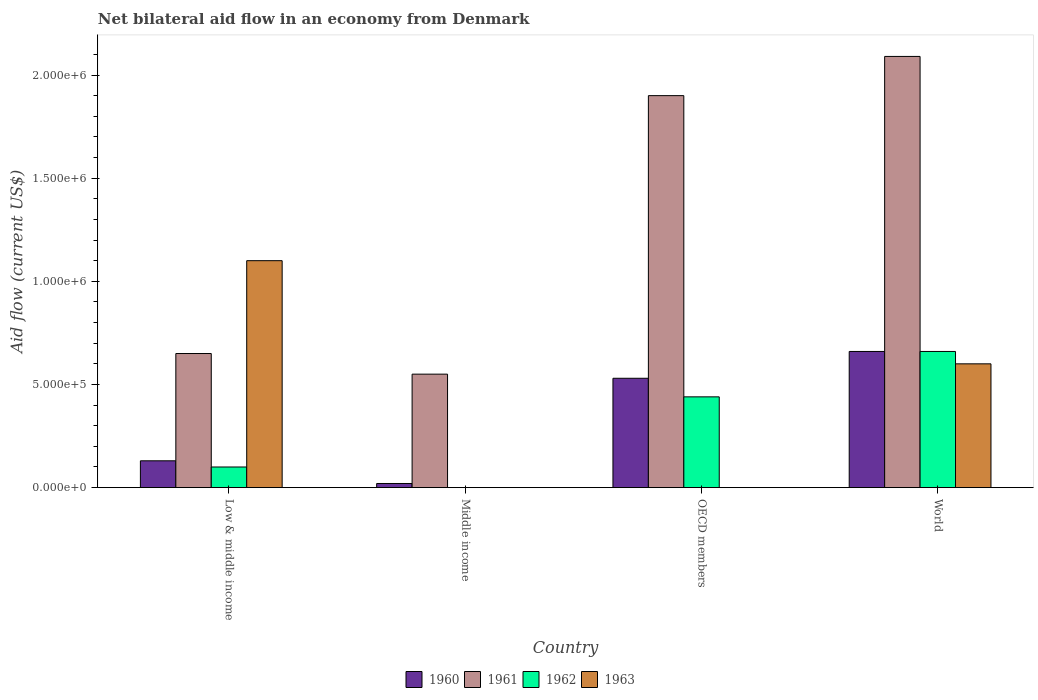How many different coloured bars are there?
Give a very brief answer. 4. Are the number of bars per tick equal to the number of legend labels?
Offer a terse response. No. Are the number of bars on each tick of the X-axis equal?
Make the answer very short. No. How many bars are there on the 4th tick from the left?
Offer a terse response. 4. How many bars are there on the 2nd tick from the right?
Ensure brevity in your answer.  3. In how many cases, is the number of bars for a given country not equal to the number of legend labels?
Make the answer very short. 2. What is the net bilateral aid flow in 1960 in OECD members?
Provide a short and direct response. 5.30e+05. Across all countries, what is the maximum net bilateral aid flow in 1961?
Offer a very short reply. 2.09e+06. In which country was the net bilateral aid flow in 1963 maximum?
Provide a succinct answer. Low & middle income. What is the total net bilateral aid flow in 1963 in the graph?
Your answer should be compact. 1.70e+06. What is the difference between the net bilateral aid flow in 1962 in OECD members and that in World?
Your answer should be very brief. -2.20e+05. What is the average net bilateral aid flow in 1960 per country?
Make the answer very short. 3.35e+05. What is the ratio of the net bilateral aid flow in 1961 in OECD members to that in World?
Ensure brevity in your answer.  0.91. Is the net bilateral aid flow in 1962 in Low & middle income less than that in World?
Provide a succinct answer. Yes. Is the difference between the net bilateral aid flow in 1963 in Low & middle income and World greater than the difference between the net bilateral aid flow in 1961 in Low & middle income and World?
Offer a terse response. Yes. What is the difference between the highest and the second highest net bilateral aid flow in 1961?
Make the answer very short. 1.44e+06. What is the difference between the highest and the lowest net bilateral aid flow in 1961?
Keep it short and to the point. 1.54e+06. Is it the case that in every country, the sum of the net bilateral aid flow in 1961 and net bilateral aid flow in 1962 is greater than the sum of net bilateral aid flow in 1960 and net bilateral aid flow in 1963?
Your answer should be compact. No. Is it the case that in every country, the sum of the net bilateral aid flow in 1960 and net bilateral aid flow in 1961 is greater than the net bilateral aid flow in 1962?
Offer a very short reply. Yes. How many bars are there?
Provide a short and direct response. 13. What is the difference between two consecutive major ticks on the Y-axis?
Make the answer very short. 5.00e+05. Are the values on the major ticks of Y-axis written in scientific E-notation?
Provide a succinct answer. Yes. Does the graph contain any zero values?
Offer a terse response. Yes. Does the graph contain grids?
Ensure brevity in your answer.  No. What is the title of the graph?
Provide a short and direct response. Net bilateral aid flow in an economy from Denmark. What is the Aid flow (current US$) in 1961 in Low & middle income?
Offer a very short reply. 6.50e+05. What is the Aid flow (current US$) in 1962 in Low & middle income?
Offer a terse response. 1.00e+05. What is the Aid flow (current US$) of 1963 in Low & middle income?
Your response must be concise. 1.10e+06. What is the Aid flow (current US$) in 1961 in Middle income?
Offer a terse response. 5.50e+05. What is the Aid flow (current US$) of 1962 in Middle income?
Your answer should be compact. 0. What is the Aid flow (current US$) of 1960 in OECD members?
Provide a short and direct response. 5.30e+05. What is the Aid flow (current US$) of 1961 in OECD members?
Keep it short and to the point. 1.90e+06. What is the Aid flow (current US$) in 1962 in OECD members?
Offer a very short reply. 4.40e+05. What is the Aid flow (current US$) in 1960 in World?
Ensure brevity in your answer.  6.60e+05. What is the Aid flow (current US$) of 1961 in World?
Give a very brief answer. 2.09e+06. Across all countries, what is the maximum Aid flow (current US$) of 1961?
Provide a succinct answer. 2.09e+06. Across all countries, what is the maximum Aid flow (current US$) in 1963?
Your answer should be very brief. 1.10e+06. Across all countries, what is the minimum Aid flow (current US$) in 1962?
Keep it short and to the point. 0. Across all countries, what is the minimum Aid flow (current US$) in 1963?
Your response must be concise. 0. What is the total Aid flow (current US$) in 1960 in the graph?
Your response must be concise. 1.34e+06. What is the total Aid flow (current US$) in 1961 in the graph?
Ensure brevity in your answer.  5.19e+06. What is the total Aid flow (current US$) in 1962 in the graph?
Provide a succinct answer. 1.20e+06. What is the total Aid flow (current US$) in 1963 in the graph?
Give a very brief answer. 1.70e+06. What is the difference between the Aid flow (current US$) in 1960 in Low & middle income and that in OECD members?
Your answer should be compact. -4.00e+05. What is the difference between the Aid flow (current US$) of 1961 in Low & middle income and that in OECD members?
Your answer should be compact. -1.25e+06. What is the difference between the Aid flow (current US$) in 1962 in Low & middle income and that in OECD members?
Offer a very short reply. -3.40e+05. What is the difference between the Aid flow (current US$) in 1960 in Low & middle income and that in World?
Make the answer very short. -5.30e+05. What is the difference between the Aid flow (current US$) of 1961 in Low & middle income and that in World?
Provide a short and direct response. -1.44e+06. What is the difference between the Aid flow (current US$) in 1962 in Low & middle income and that in World?
Ensure brevity in your answer.  -5.60e+05. What is the difference between the Aid flow (current US$) of 1960 in Middle income and that in OECD members?
Offer a very short reply. -5.10e+05. What is the difference between the Aid flow (current US$) in 1961 in Middle income and that in OECD members?
Give a very brief answer. -1.35e+06. What is the difference between the Aid flow (current US$) of 1960 in Middle income and that in World?
Offer a terse response. -6.40e+05. What is the difference between the Aid flow (current US$) in 1961 in Middle income and that in World?
Give a very brief answer. -1.54e+06. What is the difference between the Aid flow (current US$) of 1960 in OECD members and that in World?
Provide a short and direct response. -1.30e+05. What is the difference between the Aid flow (current US$) of 1961 in OECD members and that in World?
Your response must be concise. -1.90e+05. What is the difference between the Aid flow (current US$) of 1960 in Low & middle income and the Aid flow (current US$) of 1961 in Middle income?
Your response must be concise. -4.20e+05. What is the difference between the Aid flow (current US$) of 1960 in Low & middle income and the Aid flow (current US$) of 1961 in OECD members?
Ensure brevity in your answer.  -1.77e+06. What is the difference between the Aid flow (current US$) in 1960 in Low & middle income and the Aid flow (current US$) in 1962 in OECD members?
Ensure brevity in your answer.  -3.10e+05. What is the difference between the Aid flow (current US$) in 1961 in Low & middle income and the Aid flow (current US$) in 1962 in OECD members?
Provide a short and direct response. 2.10e+05. What is the difference between the Aid flow (current US$) in 1960 in Low & middle income and the Aid flow (current US$) in 1961 in World?
Your answer should be compact. -1.96e+06. What is the difference between the Aid flow (current US$) in 1960 in Low & middle income and the Aid flow (current US$) in 1962 in World?
Provide a succinct answer. -5.30e+05. What is the difference between the Aid flow (current US$) of 1960 in Low & middle income and the Aid flow (current US$) of 1963 in World?
Offer a terse response. -4.70e+05. What is the difference between the Aid flow (current US$) in 1962 in Low & middle income and the Aid flow (current US$) in 1963 in World?
Keep it short and to the point. -5.00e+05. What is the difference between the Aid flow (current US$) of 1960 in Middle income and the Aid flow (current US$) of 1961 in OECD members?
Give a very brief answer. -1.88e+06. What is the difference between the Aid flow (current US$) in 1960 in Middle income and the Aid flow (current US$) in 1962 in OECD members?
Your response must be concise. -4.20e+05. What is the difference between the Aid flow (current US$) in 1960 in Middle income and the Aid flow (current US$) in 1961 in World?
Ensure brevity in your answer.  -2.07e+06. What is the difference between the Aid flow (current US$) of 1960 in Middle income and the Aid flow (current US$) of 1962 in World?
Provide a succinct answer. -6.40e+05. What is the difference between the Aid flow (current US$) in 1960 in Middle income and the Aid flow (current US$) in 1963 in World?
Provide a short and direct response. -5.80e+05. What is the difference between the Aid flow (current US$) in 1960 in OECD members and the Aid flow (current US$) in 1961 in World?
Provide a short and direct response. -1.56e+06. What is the difference between the Aid flow (current US$) in 1960 in OECD members and the Aid flow (current US$) in 1962 in World?
Ensure brevity in your answer.  -1.30e+05. What is the difference between the Aid flow (current US$) of 1960 in OECD members and the Aid flow (current US$) of 1963 in World?
Your answer should be very brief. -7.00e+04. What is the difference between the Aid flow (current US$) in 1961 in OECD members and the Aid flow (current US$) in 1962 in World?
Make the answer very short. 1.24e+06. What is the difference between the Aid flow (current US$) of 1961 in OECD members and the Aid flow (current US$) of 1963 in World?
Your answer should be compact. 1.30e+06. What is the difference between the Aid flow (current US$) in 1962 in OECD members and the Aid flow (current US$) in 1963 in World?
Give a very brief answer. -1.60e+05. What is the average Aid flow (current US$) of 1960 per country?
Your answer should be very brief. 3.35e+05. What is the average Aid flow (current US$) of 1961 per country?
Ensure brevity in your answer.  1.30e+06. What is the average Aid flow (current US$) in 1962 per country?
Make the answer very short. 3.00e+05. What is the average Aid flow (current US$) of 1963 per country?
Give a very brief answer. 4.25e+05. What is the difference between the Aid flow (current US$) in 1960 and Aid flow (current US$) in 1961 in Low & middle income?
Provide a short and direct response. -5.20e+05. What is the difference between the Aid flow (current US$) of 1960 and Aid flow (current US$) of 1962 in Low & middle income?
Make the answer very short. 3.00e+04. What is the difference between the Aid flow (current US$) of 1960 and Aid flow (current US$) of 1963 in Low & middle income?
Your answer should be very brief. -9.70e+05. What is the difference between the Aid flow (current US$) of 1961 and Aid flow (current US$) of 1963 in Low & middle income?
Your answer should be compact. -4.50e+05. What is the difference between the Aid flow (current US$) of 1962 and Aid flow (current US$) of 1963 in Low & middle income?
Your answer should be compact. -1.00e+06. What is the difference between the Aid flow (current US$) in 1960 and Aid flow (current US$) in 1961 in Middle income?
Ensure brevity in your answer.  -5.30e+05. What is the difference between the Aid flow (current US$) of 1960 and Aid flow (current US$) of 1961 in OECD members?
Offer a terse response. -1.37e+06. What is the difference between the Aid flow (current US$) of 1961 and Aid flow (current US$) of 1962 in OECD members?
Provide a short and direct response. 1.46e+06. What is the difference between the Aid flow (current US$) of 1960 and Aid flow (current US$) of 1961 in World?
Your response must be concise. -1.43e+06. What is the difference between the Aid flow (current US$) of 1961 and Aid flow (current US$) of 1962 in World?
Your answer should be very brief. 1.43e+06. What is the difference between the Aid flow (current US$) of 1961 and Aid flow (current US$) of 1963 in World?
Your answer should be very brief. 1.49e+06. What is the difference between the Aid flow (current US$) in 1962 and Aid flow (current US$) in 1963 in World?
Offer a very short reply. 6.00e+04. What is the ratio of the Aid flow (current US$) of 1960 in Low & middle income to that in Middle income?
Offer a terse response. 6.5. What is the ratio of the Aid flow (current US$) in 1961 in Low & middle income to that in Middle income?
Make the answer very short. 1.18. What is the ratio of the Aid flow (current US$) in 1960 in Low & middle income to that in OECD members?
Your answer should be very brief. 0.25. What is the ratio of the Aid flow (current US$) of 1961 in Low & middle income to that in OECD members?
Keep it short and to the point. 0.34. What is the ratio of the Aid flow (current US$) of 1962 in Low & middle income to that in OECD members?
Keep it short and to the point. 0.23. What is the ratio of the Aid flow (current US$) in 1960 in Low & middle income to that in World?
Make the answer very short. 0.2. What is the ratio of the Aid flow (current US$) of 1961 in Low & middle income to that in World?
Ensure brevity in your answer.  0.31. What is the ratio of the Aid flow (current US$) of 1962 in Low & middle income to that in World?
Give a very brief answer. 0.15. What is the ratio of the Aid flow (current US$) of 1963 in Low & middle income to that in World?
Offer a terse response. 1.83. What is the ratio of the Aid flow (current US$) of 1960 in Middle income to that in OECD members?
Your answer should be very brief. 0.04. What is the ratio of the Aid flow (current US$) in 1961 in Middle income to that in OECD members?
Make the answer very short. 0.29. What is the ratio of the Aid flow (current US$) in 1960 in Middle income to that in World?
Make the answer very short. 0.03. What is the ratio of the Aid flow (current US$) in 1961 in Middle income to that in World?
Your answer should be very brief. 0.26. What is the ratio of the Aid flow (current US$) in 1960 in OECD members to that in World?
Make the answer very short. 0.8. What is the ratio of the Aid flow (current US$) of 1961 in OECD members to that in World?
Provide a succinct answer. 0.91. What is the difference between the highest and the second highest Aid flow (current US$) of 1960?
Make the answer very short. 1.30e+05. What is the difference between the highest and the lowest Aid flow (current US$) in 1960?
Your response must be concise. 6.40e+05. What is the difference between the highest and the lowest Aid flow (current US$) in 1961?
Your response must be concise. 1.54e+06. What is the difference between the highest and the lowest Aid flow (current US$) of 1963?
Make the answer very short. 1.10e+06. 